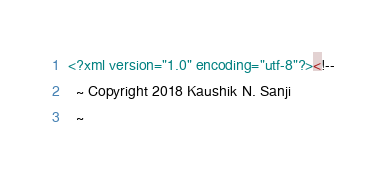<code> <loc_0><loc_0><loc_500><loc_500><_XML_><?xml version="1.0" encoding="utf-8"?><!--
  ~ Copyright 2018 Kaushik N. Sanji
  ~</code> 